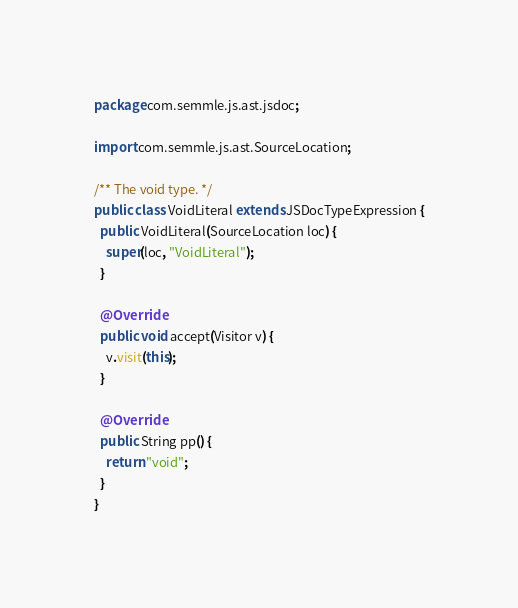<code> <loc_0><loc_0><loc_500><loc_500><_Java_>package com.semmle.js.ast.jsdoc;

import com.semmle.js.ast.SourceLocation;

/** The void type. */
public class VoidLiteral extends JSDocTypeExpression {
  public VoidLiteral(SourceLocation loc) {
    super(loc, "VoidLiteral");
  }

  @Override
  public void accept(Visitor v) {
    v.visit(this);
  }

  @Override
  public String pp() {
    return "void";
  }
}
</code> 